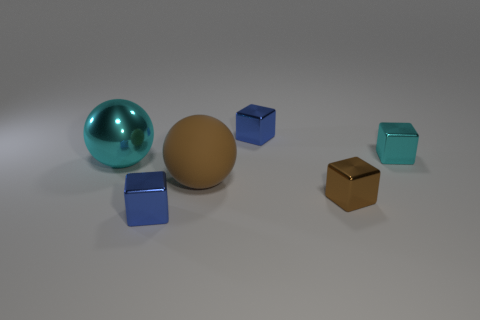Add 1 big cyan metallic balls. How many objects exist? 7 Subtract all balls. How many objects are left? 4 Subtract 0 yellow spheres. How many objects are left? 6 Subtract all large yellow objects. Subtract all big metal balls. How many objects are left? 5 Add 1 brown metal objects. How many brown metal objects are left? 2 Add 4 tiny shiny things. How many tiny shiny things exist? 8 